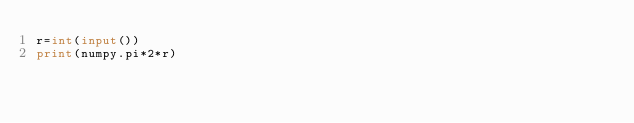Convert code to text. <code><loc_0><loc_0><loc_500><loc_500><_Python_>r=int(input())
print(numpy.pi*2*r)</code> 